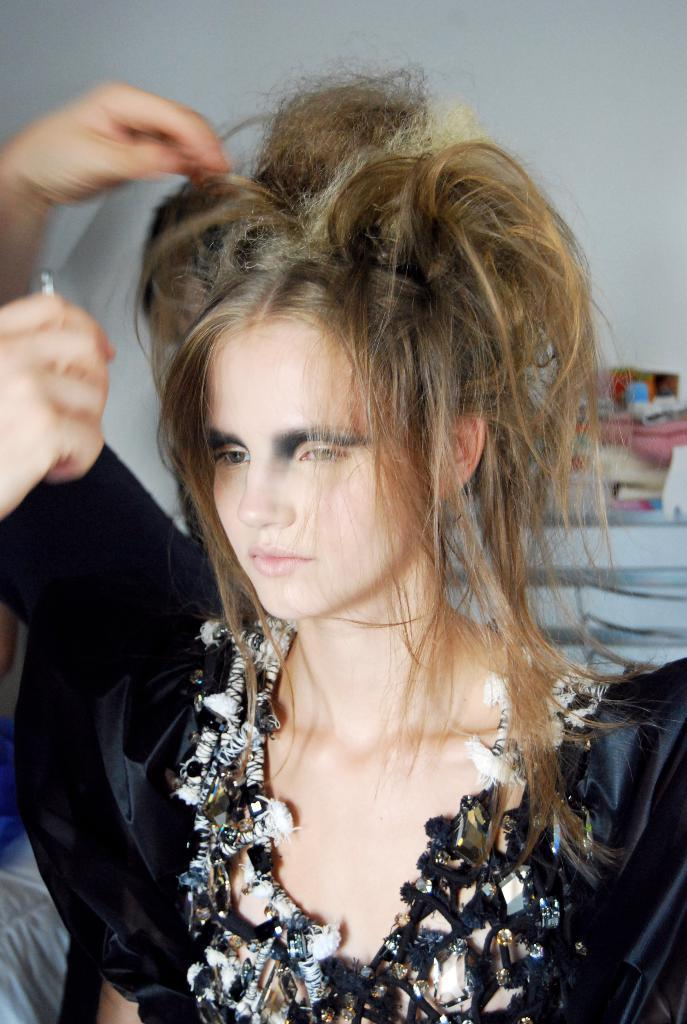Who is the main subject in the image? There is a girl in the image. What is the girl wearing? The girl is wearing a black dress. In which direction is the girl looking? The girl is looking to the left side of the image. Is there a boy holding a parcel for the girl in the image? There is no boy or parcel present in the image. What is the relation between the girl and the person standing next to her in the image? There is no person standing next to the girl in the image. 